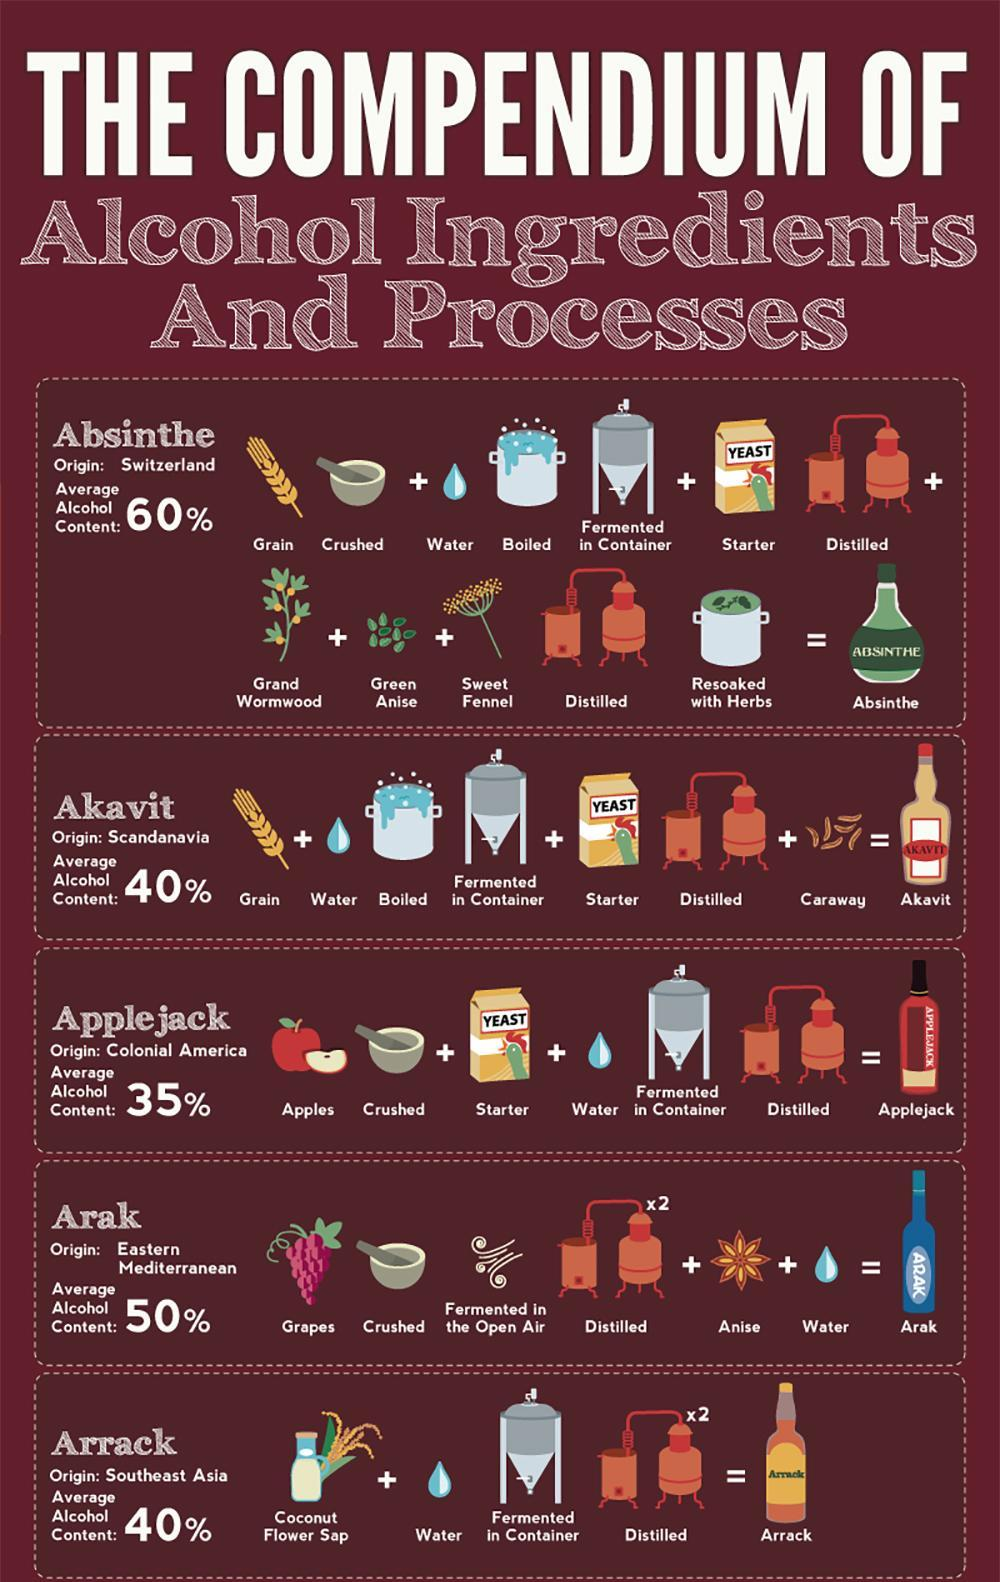What is the main ingredient of Arrack?
Answer the question with a short phrase. Coconut Flower Sap How many processes are involved in making of Applejack? 3 How many different varieties of Alcohol are mentioned in the info graphic? 5 How many Ingredients are required for the preparation of Absinthe? 7 In which variety of Alcohol is Anise an ingredient? Arak How many Ingredients are required for the preparation of Arak? 3 How many Ingredients are required for the preparation of Akavit? 4 How many processes are involved in making of Absinthe? 5 How many processes are involved in making of Arak? 3 How many processes are involved in making of Akavit? 3 